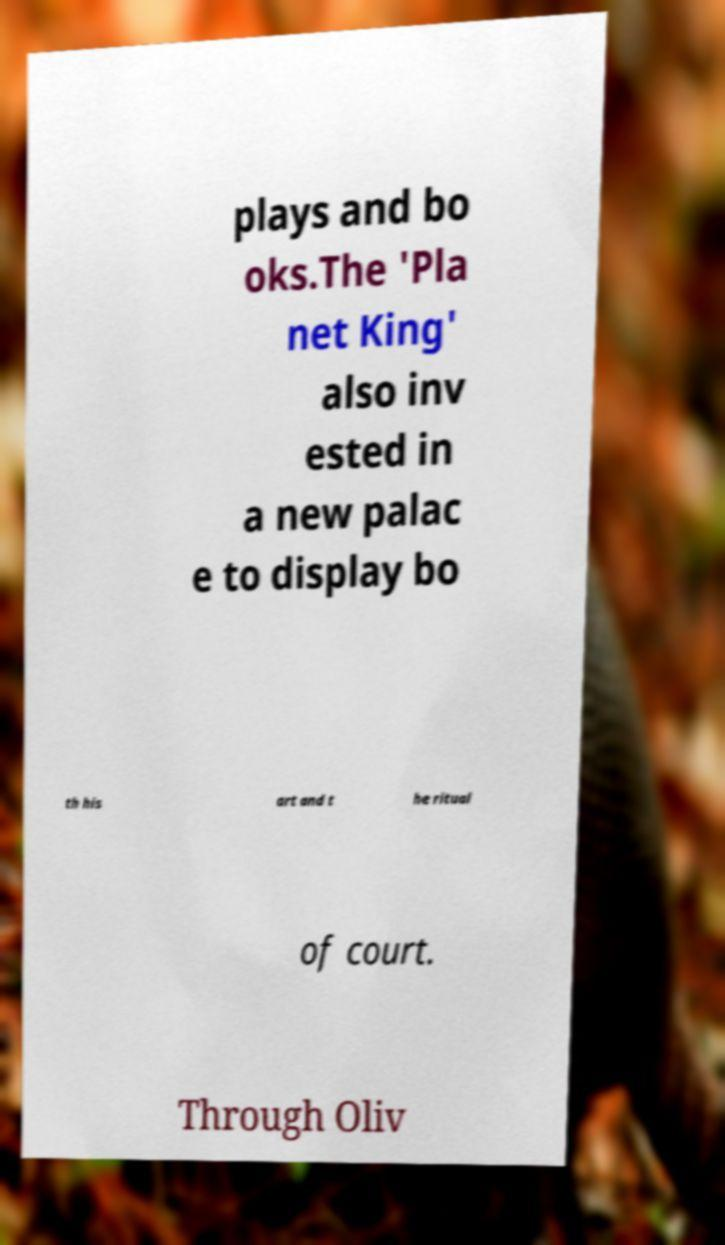There's text embedded in this image that I need extracted. Can you transcribe it verbatim? plays and bo oks.The 'Pla net King' also inv ested in a new palac e to display bo th his art and t he ritual of court. Through Oliv 